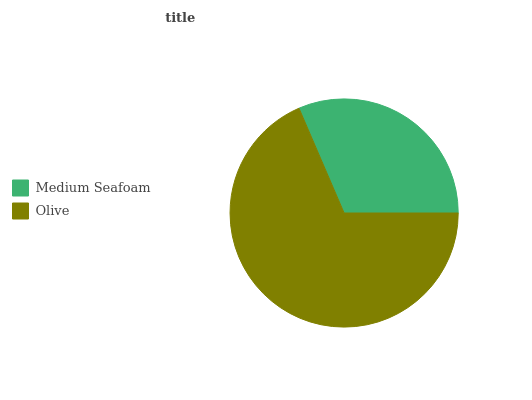Is Medium Seafoam the minimum?
Answer yes or no. Yes. Is Olive the maximum?
Answer yes or no. Yes. Is Olive the minimum?
Answer yes or no. No. Is Olive greater than Medium Seafoam?
Answer yes or no. Yes. Is Medium Seafoam less than Olive?
Answer yes or no. Yes. Is Medium Seafoam greater than Olive?
Answer yes or no. No. Is Olive less than Medium Seafoam?
Answer yes or no. No. Is Olive the high median?
Answer yes or no. Yes. Is Medium Seafoam the low median?
Answer yes or no. Yes. Is Medium Seafoam the high median?
Answer yes or no. No. Is Olive the low median?
Answer yes or no. No. 